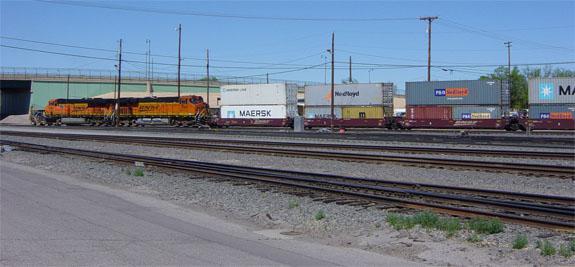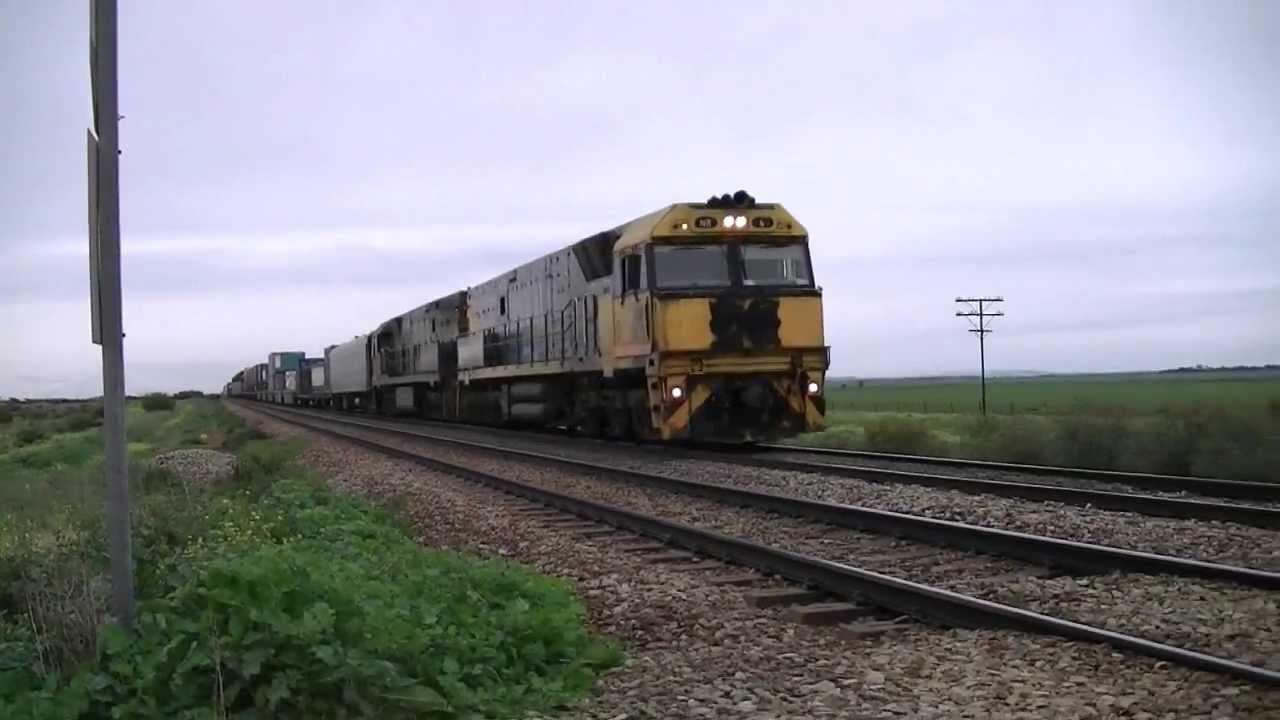The first image is the image on the left, the second image is the image on the right. For the images shown, is this caption "An image shows a train going under a structure that spans the tracks with a zig-zag structural element." true? Answer yes or no. No. The first image is the image on the left, the second image is the image on the right. Assess this claim about the two images: "A predominantly yellow train is traveling slightly towards the right.". Correct or not? Answer yes or no. Yes. 